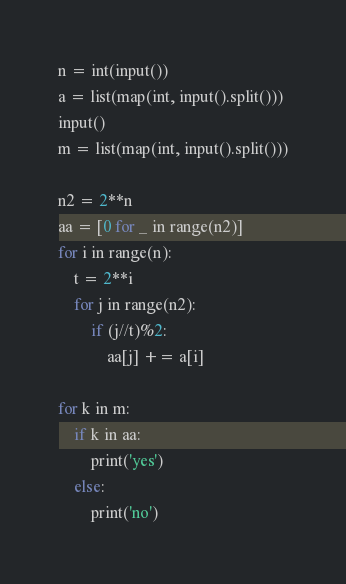<code> <loc_0><loc_0><loc_500><loc_500><_Python_>n = int(input())
a = list(map(int, input().split()))
input()
m = list(map(int, input().split()))

n2 = 2**n
aa = [0 for _ in range(n2)]
for i in range(n):
    t = 2**i
    for j in range(n2):
        if (j//t)%2:
            aa[j] += a[i]

for k in m:
    if k in aa:
        print('yes')
    else:
        print('no')</code> 